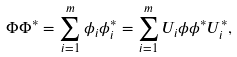<formula> <loc_0><loc_0><loc_500><loc_500>\Phi \Phi ^ { * } = \sum _ { i = 1 } ^ { m } \phi _ { i } \phi _ { i } ^ { * } = \sum _ { i = 1 } ^ { m } U _ { i } \phi \phi ^ { * } U _ { i } ^ { * } ,</formula> 